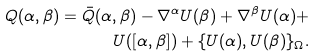Convert formula to latex. <formula><loc_0><loc_0><loc_500><loc_500>Q ( \alpha , \beta ) = \bar { Q } ( \alpha , \beta ) - \nabla ^ { \alpha } U ( \beta ) + \nabla ^ { \beta } U ( \alpha ) + \\ U ( [ \alpha , \beta ] ) + \{ U ( \alpha ) , U ( \beta ) \} _ { \Omega } .</formula> 